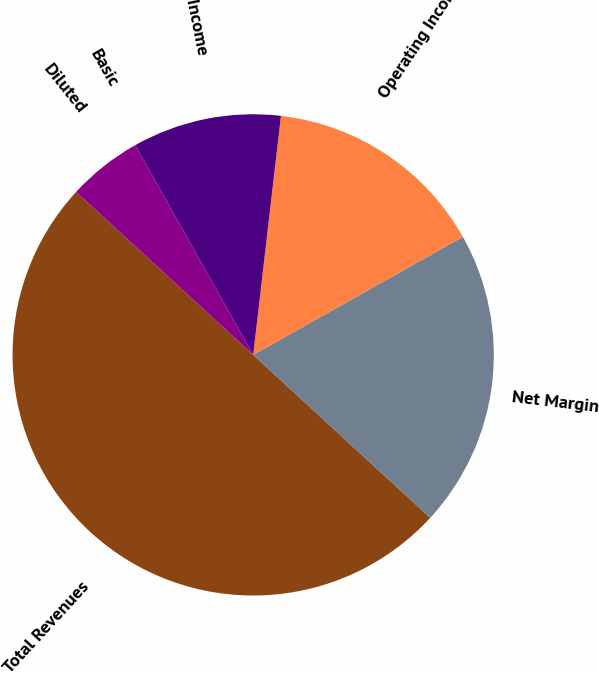Convert chart to OTSL. <chart><loc_0><loc_0><loc_500><loc_500><pie_chart><fcel>Total Revenues<fcel>Net Margin<fcel>Operating Income<fcel>Net Income<fcel>Basic<fcel>Diluted<nl><fcel>50.0%<fcel>20.0%<fcel>15.0%<fcel>10.0%<fcel>0.0%<fcel>5.0%<nl></chart> 